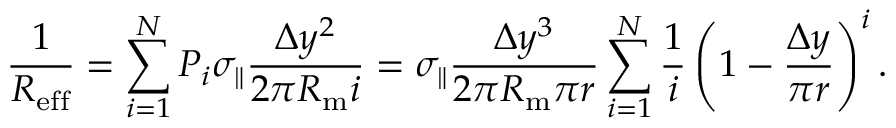<formula> <loc_0><loc_0><loc_500><loc_500>\frac { 1 } { R _ { e f f } } = \sum _ { i = 1 } ^ { N } P _ { i } \sigma _ { \| } \frac { \Delta y ^ { 2 } } { 2 \pi R _ { m } i } = \sigma _ { \| } \frac { \Delta y ^ { 3 } } { 2 \pi R _ { m } \pi r } \sum _ { i = 1 } ^ { N } \frac { 1 } { i } \left ( 1 - \frac { \Delta y } { \pi r } \right ) ^ { i } .</formula> 